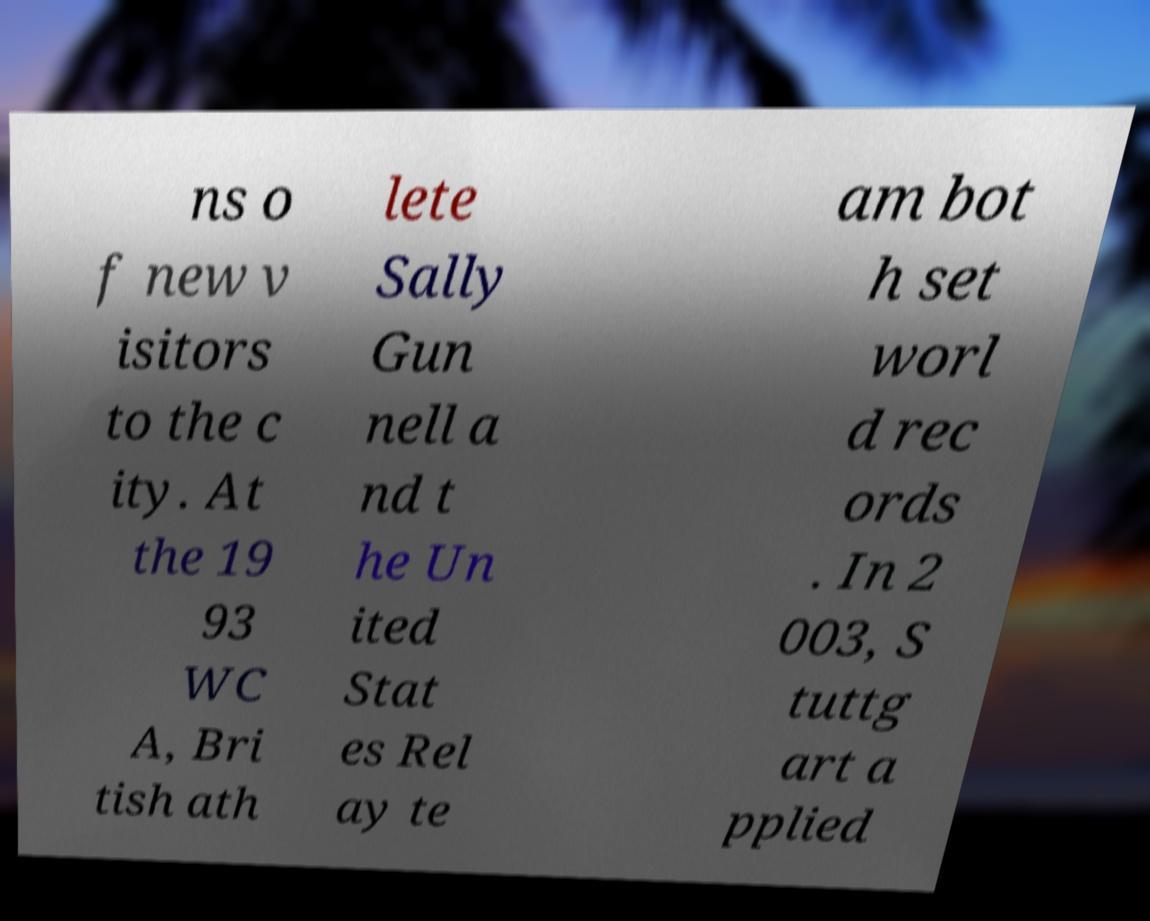What messages or text are displayed in this image? I need them in a readable, typed format. ns o f new v isitors to the c ity. At the 19 93 WC A, Bri tish ath lete Sally Gun nell a nd t he Un ited Stat es Rel ay te am bot h set worl d rec ords . In 2 003, S tuttg art a pplied 